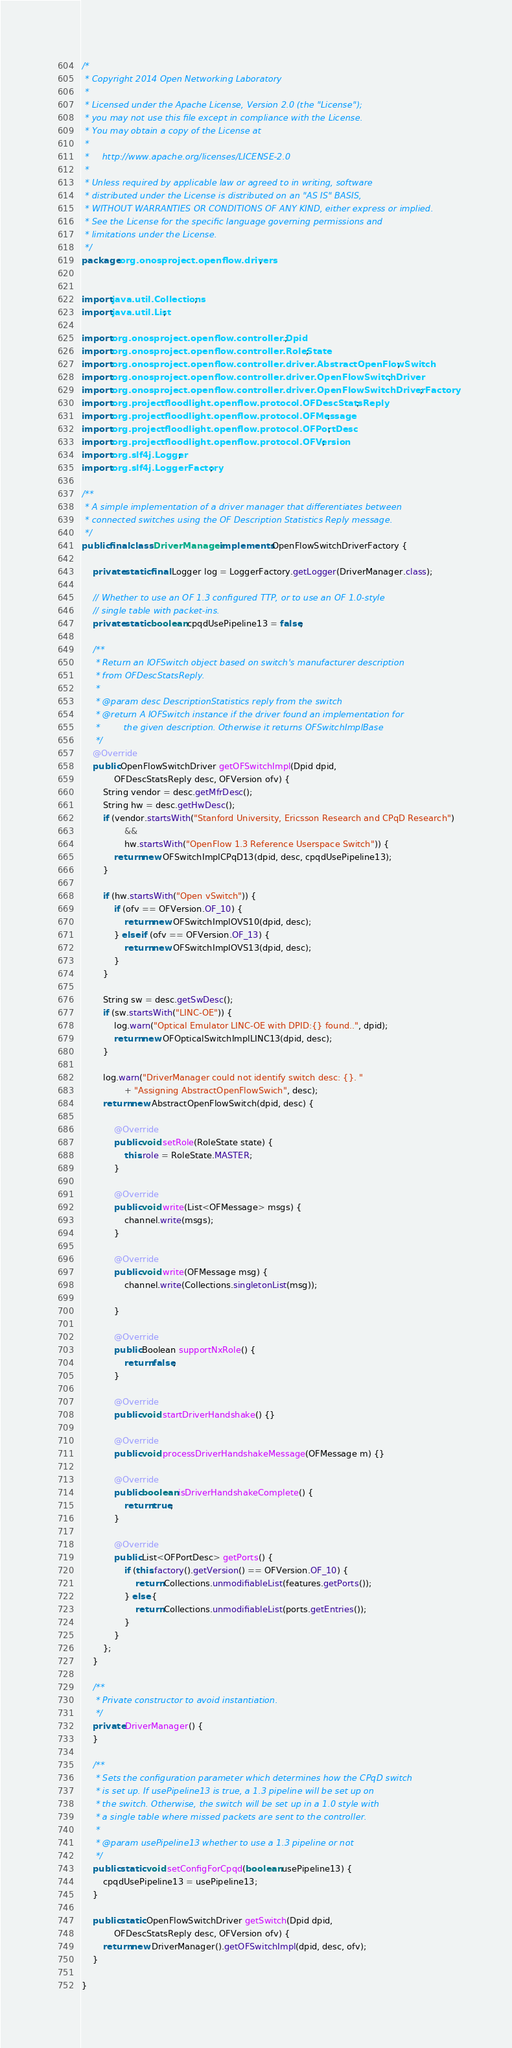Convert code to text. <code><loc_0><loc_0><loc_500><loc_500><_Java_>/*
 * Copyright 2014 Open Networking Laboratory
 *
 * Licensed under the Apache License, Version 2.0 (the "License");
 * you may not use this file except in compliance with the License.
 * You may obtain a copy of the License at
 *
 *     http://www.apache.org/licenses/LICENSE-2.0
 *
 * Unless required by applicable law or agreed to in writing, software
 * distributed under the License is distributed on an "AS IS" BASIS,
 * WITHOUT WARRANTIES OR CONDITIONS OF ANY KIND, either express or implied.
 * See the License for the specific language governing permissions and
 * limitations under the License.
 */
package org.onosproject.openflow.drivers;


import java.util.Collections;
import java.util.List;

import org.onosproject.openflow.controller.Dpid;
import org.onosproject.openflow.controller.RoleState;
import org.onosproject.openflow.controller.driver.AbstractOpenFlowSwitch;
import org.onosproject.openflow.controller.driver.OpenFlowSwitchDriver;
import org.onosproject.openflow.controller.driver.OpenFlowSwitchDriverFactory;
import org.projectfloodlight.openflow.protocol.OFDescStatsReply;
import org.projectfloodlight.openflow.protocol.OFMessage;
import org.projectfloodlight.openflow.protocol.OFPortDesc;
import org.projectfloodlight.openflow.protocol.OFVersion;
import org.slf4j.Logger;
import org.slf4j.LoggerFactory;

/**
 * A simple implementation of a driver manager that differentiates between
 * connected switches using the OF Description Statistics Reply message.
 */
public final class DriverManager implements OpenFlowSwitchDriverFactory {

    private static final Logger log = LoggerFactory.getLogger(DriverManager.class);

    // Whether to use an OF 1.3 configured TTP, or to use an OF 1.0-style
    // single table with packet-ins.
    private static boolean cpqdUsePipeline13 = false;

    /**
     * Return an IOFSwitch object based on switch's manufacturer description
     * from OFDescStatsReply.
     *
     * @param desc DescriptionStatistics reply from the switch
     * @return A IOFSwitch instance if the driver found an implementation for
     *         the given description. Otherwise it returns OFSwitchImplBase
     */
    @Override
    public OpenFlowSwitchDriver getOFSwitchImpl(Dpid dpid,
            OFDescStatsReply desc, OFVersion ofv) {
        String vendor = desc.getMfrDesc();
        String hw = desc.getHwDesc();
        if (vendor.startsWith("Stanford University, Ericsson Research and CPqD Research")
                &&
                hw.startsWith("OpenFlow 1.3 Reference Userspace Switch")) {
            return new OFSwitchImplCPqD13(dpid, desc, cpqdUsePipeline13);
        }

        if (hw.startsWith("Open vSwitch")) {
            if (ofv == OFVersion.OF_10) {
                return new OFSwitchImplOVS10(dpid, desc);
            } else if (ofv == OFVersion.OF_13) {
                return new OFSwitchImplOVS13(dpid, desc);
            }
        }

        String sw = desc.getSwDesc();
        if (sw.startsWith("LINC-OE")) {
            log.warn("Optical Emulator LINC-OE with DPID:{} found..", dpid);
            return new OFOpticalSwitchImplLINC13(dpid, desc);
        }

        log.warn("DriverManager could not identify switch desc: {}. "
                + "Assigning AbstractOpenFlowSwich", desc);
        return new AbstractOpenFlowSwitch(dpid, desc) {

            @Override
            public void setRole(RoleState state) {
                this.role = RoleState.MASTER;
            }

            @Override
            public void write(List<OFMessage> msgs) {
                channel.write(msgs);
            }

            @Override
            public void write(OFMessage msg) {
                channel.write(Collections.singletonList(msg));

            }

            @Override
            public Boolean supportNxRole() {
                return false;
            }

            @Override
            public void startDriverHandshake() {}

            @Override
            public void processDriverHandshakeMessage(OFMessage m) {}

            @Override
            public boolean isDriverHandshakeComplete() {
                return true;
            }

            @Override
            public List<OFPortDesc> getPorts() {
                if (this.factory().getVersion() == OFVersion.OF_10) {
                    return Collections.unmodifiableList(features.getPorts());
                } else {
                    return Collections.unmodifiableList(ports.getEntries());
                }
            }
        };
    }

    /**
     * Private constructor to avoid instantiation.
     */
    private DriverManager() {
    }

    /**
     * Sets the configuration parameter which determines how the CPqD switch
     * is set up. If usePipeline13 is true, a 1.3 pipeline will be set up on
     * the switch. Otherwise, the switch will be set up in a 1.0 style with
     * a single table where missed packets are sent to the controller.
     *
     * @param usePipeline13 whether to use a 1.3 pipeline or not
     */
    public static void setConfigForCpqd(boolean usePipeline13) {
        cpqdUsePipeline13 = usePipeline13;
    }

    public static OpenFlowSwitchDriver getSwitch(Dpid dpid,
            OFDescStatsReply desc, OFVersion ofv) {
        return new DriverManager().getOFSwitchImpl(dpid, desc, ofv);
    }

}
</code> 